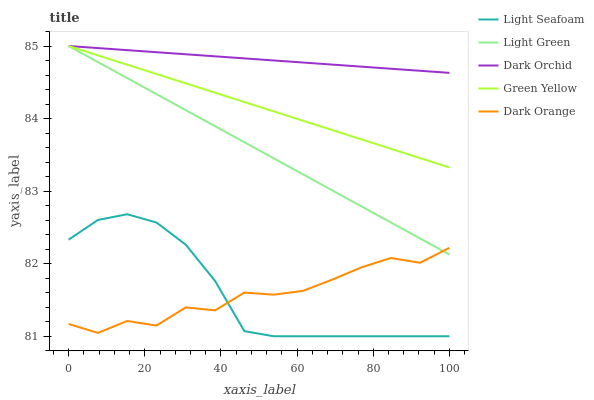Does Dark Orange have the minimum area under the curve?
Answer yes or no. Yes. Does Dark Orchid have the maximum area under the curve?
Answer yes or no. Yes. Does Green Yellow have the minimum area under the curve?
Answer yes or no. No. Does Green Yellow have the maximum area under the curve?
Answer yes or no. No. Is Dark Orchid the smoothest?
Answer yes or no. Yes. Is Dark Orange the roughest?
Answer yes or no. Yes. Is Green Yellow the smoothest?
Answer yes or no. No. Is Green Yellow the roughest?
Answer yes or no. No. Does Light Seafoam have the lowest value?
Answer yes or no. Yes. Does Green Yellow have the lowest value?
Answer yes or no. No. Does Light Green have the highest value?
Answer yes or no. Yes. Does Light Seafoam have the highest value?
Answer yes or no. No. Is Dark Orange less than Green Yellow?
Answer yes or no. Yes. Is Green Yellow greater than Light Seafoam?
Answer yes or no. Yes. Does Green Yellow intersect Light Green?
Answer yes or no. Yes. Is Green Yellow less than Light Green?
Answer yes or no. No. Is Green Yellow greater than Light Green?
Answer yes or no. No. Does Dark Orange intersect Green Yellow?
Answer yes or no. No. 